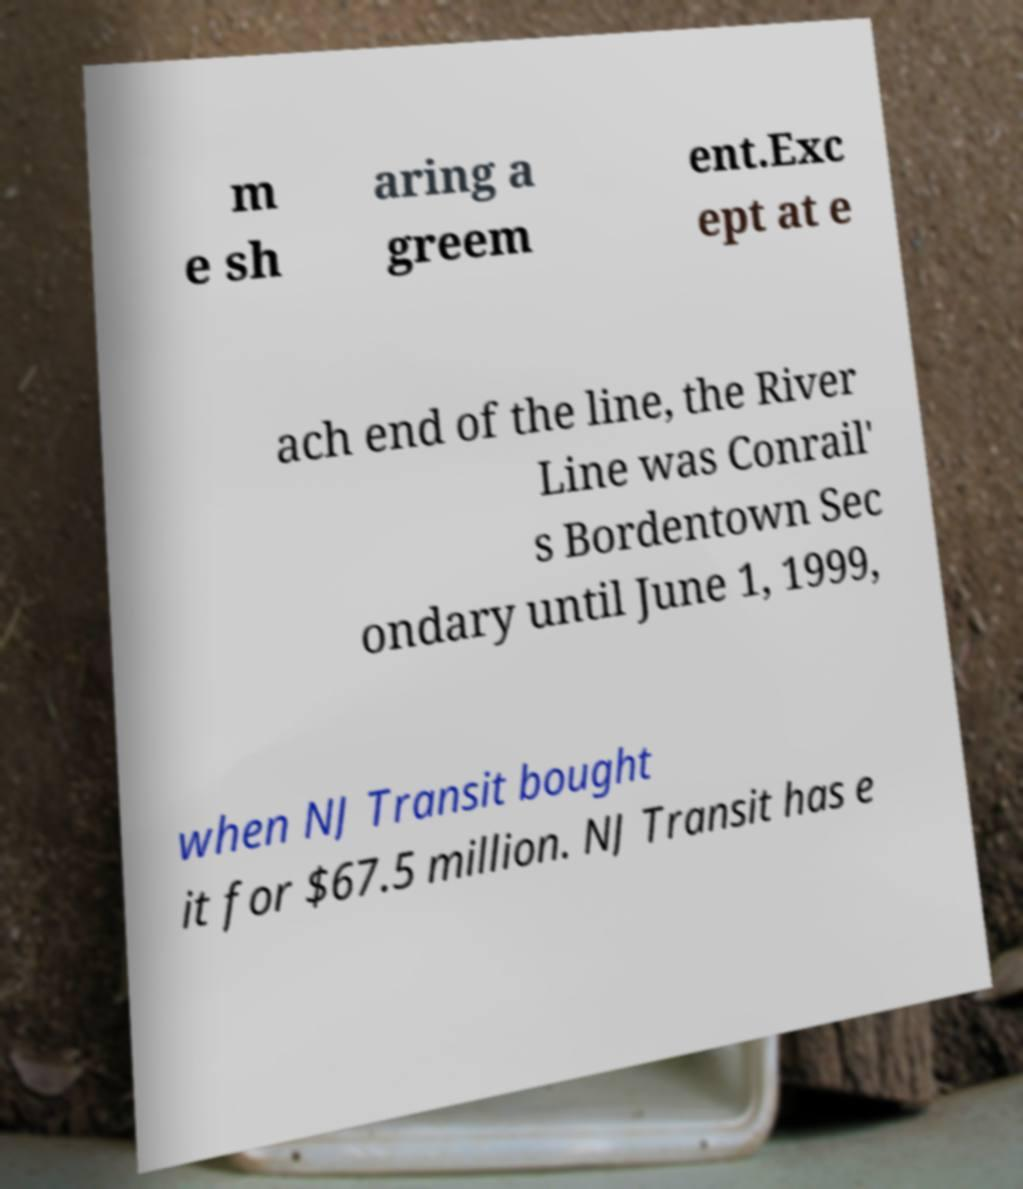Could you extract and type out the text from this image? m e sh aring a greem ent.Exc ept at e ach end of the line, the River Line was Conrail' s Bordentown Sec ondary until June 1, 1999, when NJ Transit bought it for $67.5 million. NJ Transit has e 